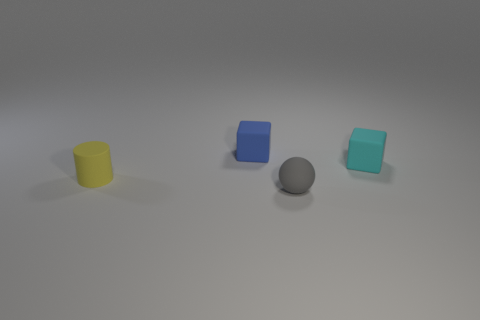The small blue object that is made of the same material as the small ball is what shape?
Offer a terse response. Cube. What number of other objects are there of the same shape as the tiny gray object?
Provide a succinct answer. 0. What shape is the object that is on the left side of the small rubber block behind the rubber object right of the small gray rubber thing?
Provide a succinct answer. Cylinder. What number of cylinders are either tiny gray rubber objects or blue objects?
Offer a very short reply. 0. Are there any rubber blocks to the left of the rubber object that is in front of the yellow matte cylinder?
Provide a short and direct response. Yes. Is there anything else that is made of the same material as the yellow object?
Make the answer very short. Yes. Does the small yellow thing have the same shape as the small matte thing that is in front of the cylinder?
Your answer should be compact. No. What number of other objects are the same size as the ball?
Your answer should be compact. 3. How many brown things are either tiny matte balls or tiny matte objects?
Give a very brief answer. 0. What number of tiny rubber objects are behind the rubber cylinder and left of the gray rubber ball?
Offer a very short reply. 1. 